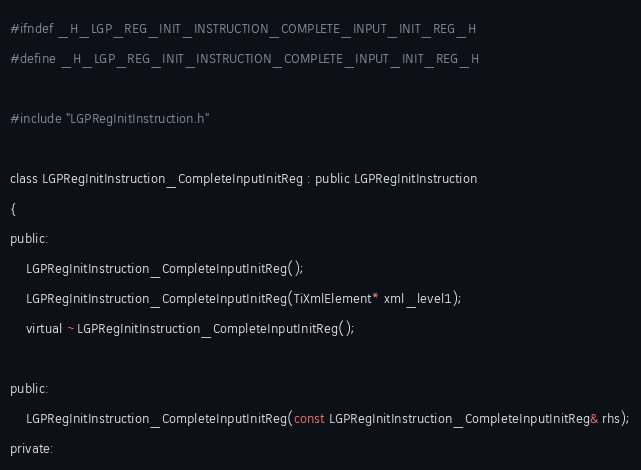Convert code to text. <code><loc_0><loc_0><loc_500><loc_500><_C_>#ifndef _H_LGP_REG_INIT_INSTRUCTION_COMPLETE_INPUT_INIT_REG_H
#define _H_LGP_REG_INIT_INSTRUCTION_COMPLETE_INPUT_INIT_REG_H

#include "LGPRegInitInstruction.h"

class LGPRegInitInstruction_CompleteInputInitReg : public LGPRegInitInstruction
{
public:
	LGPRegInitInstruction_CompleteInputInitReg();
	LGPRegInitInstruction_CompleteInputInitReg(TiXmlElement* xml_level1);
	virtual ~LGPRegInitInstruction_CompleteInputInitReg();

public:
	LGPRegInitInstruction_CompleteInputInitReg(const LGPRegInitInstruction_CompleteInputInitReg& rhs);
private:</code> 